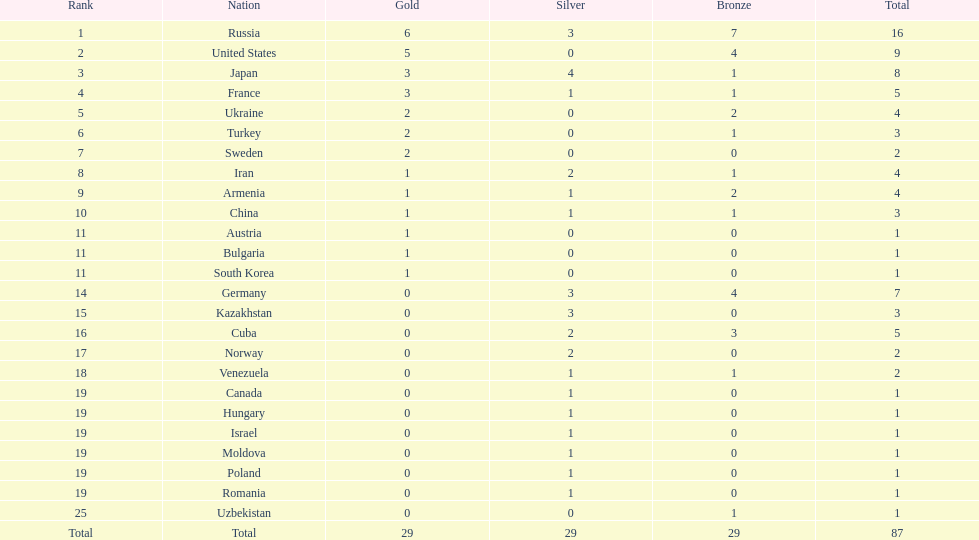Who ranked right after turkey? Sweden. 